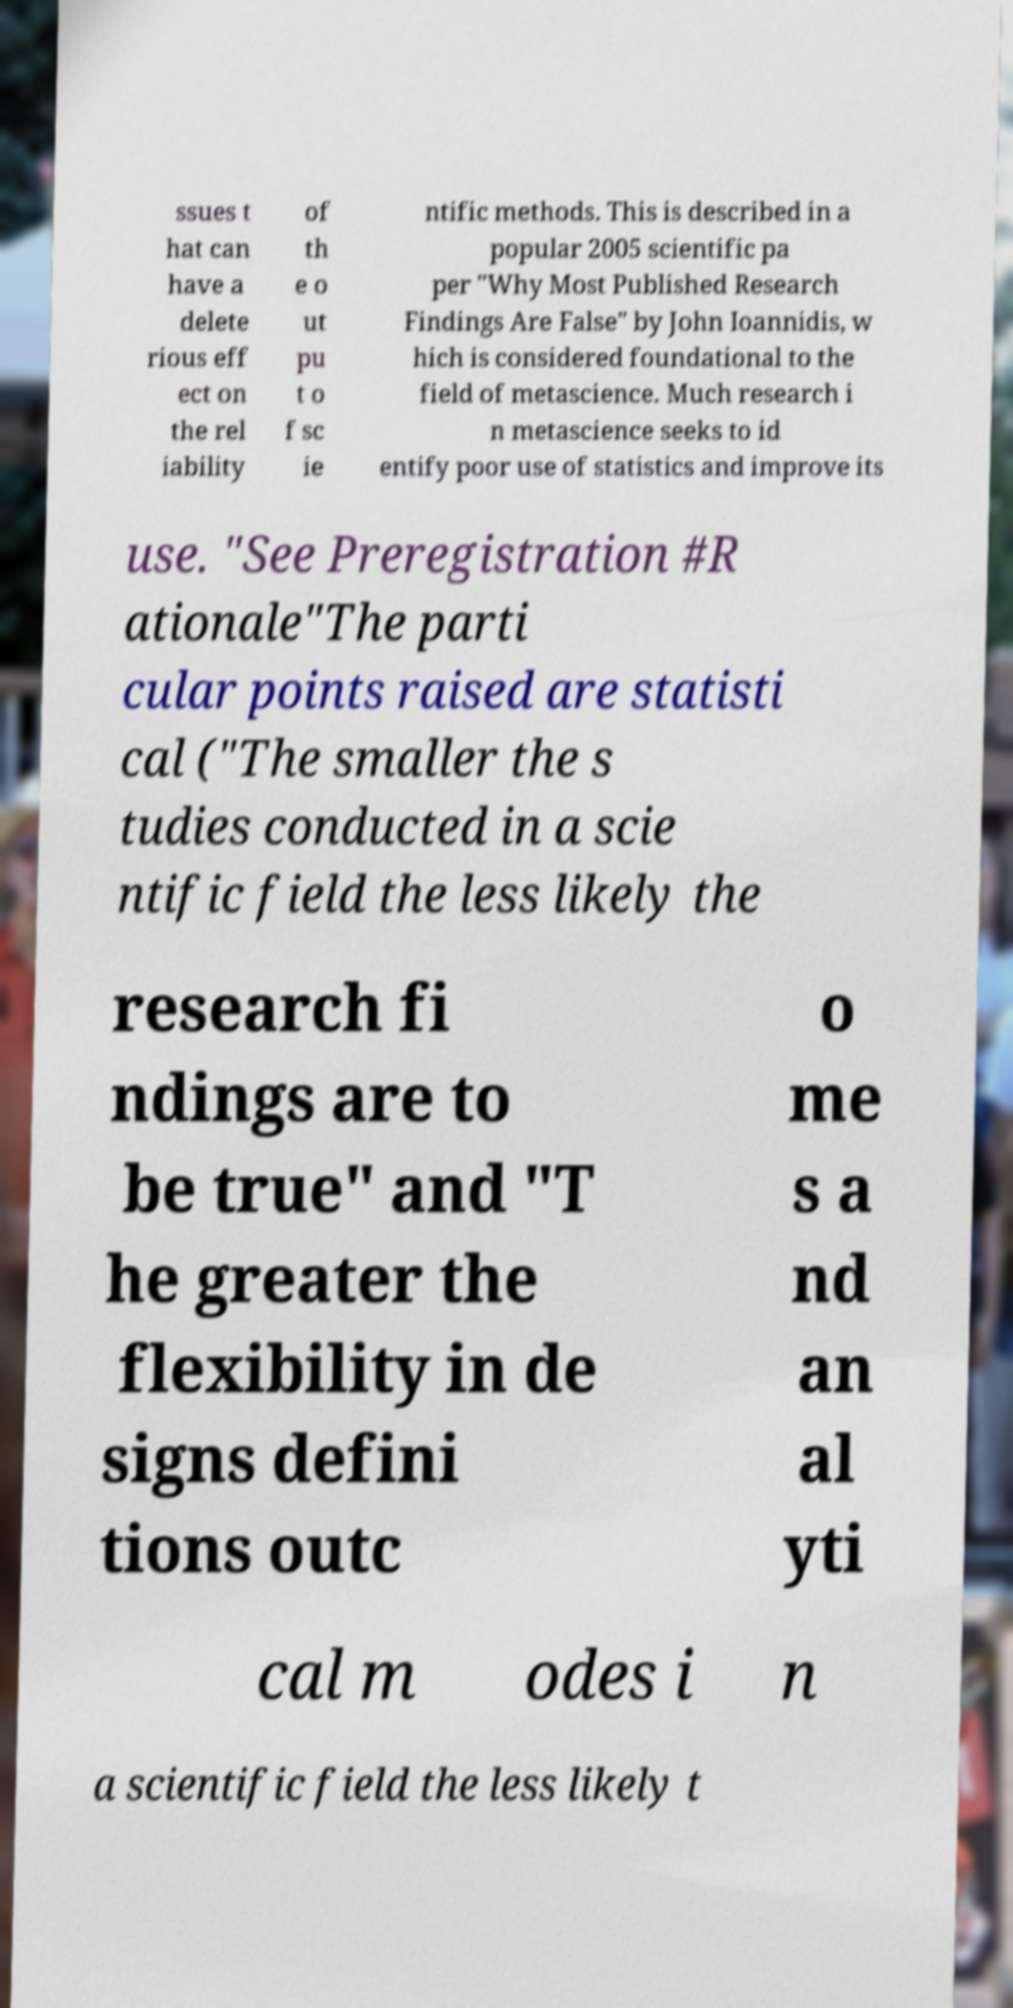Please identify and transcribe the text found in this image. ssues t hat can have a delete rious eff ect on the rel iability of th e o ut pu t o f sc ie ntific methods. This is described in a popular 2005 scientific pa per "Why Most Published Research Findings Are False" by John Ioannidis, w hich is considered foundational to the field of metascience. Much research i n metascience seeks to id entify poor use of statistics and improve its use. "See Preregistration #R ationale"The parti cular points raised are statisti cal ("The smaller the s tudies conducted in a scie ntific field the less likely the research fi ndings are to be true" and "T he greater the flexibility in de signs defini tions outc o me s a nd an al yti cal m odes i n a scientific field the less likely t 